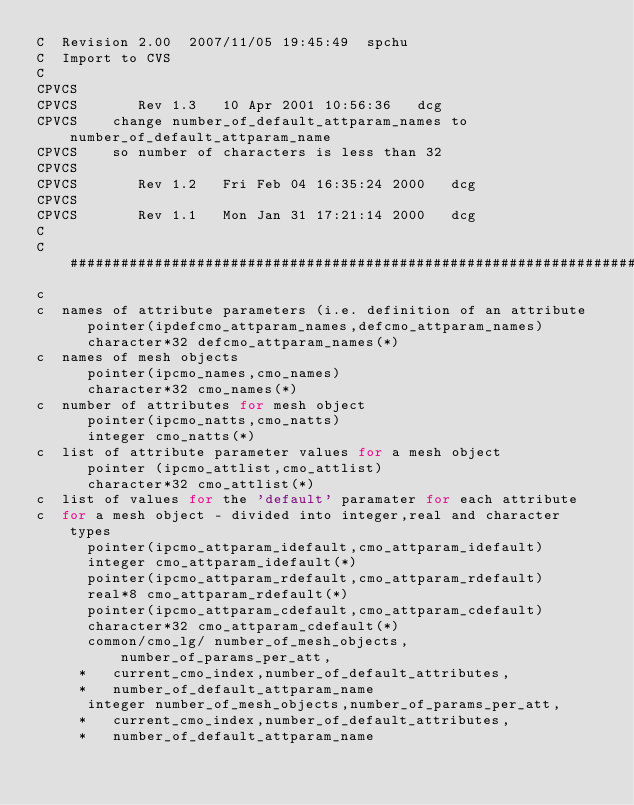Convert code to text. <code><loc_0><loc_0><loc_500><loc_500><_C_>C  Revision 2.00  2007/11/05 19:45:49  spchu
C  Import to CVS
C
CPVCS    
CPVCS       Rev 1.3   10 Apr 2001 10:56:36   dcg
CPVCS    change number_of_default_attparam_names to number_of_default_attparam_name
CPVCS    so number of characters is less than 32
CPVCS
CPVCS       Rev 1.2   Fri Feb 04 16:35:24 2000   dcg
CPVCS
CPVCS       Rev 1.1   Mon Jan 31 17:21:14 2000   dcg
C
C#######################################################################
c
c  names of attribute parameters (i.e. definition of an attribute
      pointer(ipdefcmo_attparam_names,defcmo_attparam_names)
      character*32 defcmo_attparam_names(*)
c  names of mesh objects
      pointer(ipcmo_names,cmo_names)
      character*32 cmo_names(*)
c  number of attributes for mesh object
      pointer(ipcmo_natts,cmo_natts)
      integer cmo_natts(*)
c  list of attribute parameter values for a mesh object
      pointer (ipcmo_attlist,cmo_attlist)
      character*32 cmo_attlist(*)
c  list of values for the 'default' paramater for each attribute
c  for a mesh object - divided into integer,real and character types
      pointer(ipcmo_attparam_idefault,cmo_attparam_idefault)
      integer cmo_attparam_idefault(*)
      pointer(ipcmo_attparam_rdefault,cmo_attparam_rdefault)
      real*8 cmo_attparam_rdefault(*)
      pointer(ipcmo_attparam_cdefault,cmo_attparam_cdefault)
      character*32 cmo_attparam_cdefault(*)
      common/cmo_lg/ number_of_mesh_objects,number_of_params_per_att,
     *   current_cmo_index,number_of_default_attributes,
     *   number_of_default_attparam_name
      integer number_of_mesh_objects,number_of_params_per_att,
     *   current_cmo_index,number_of_default_attributes,
     *   number_of_default_attparam_name
 
</code> 